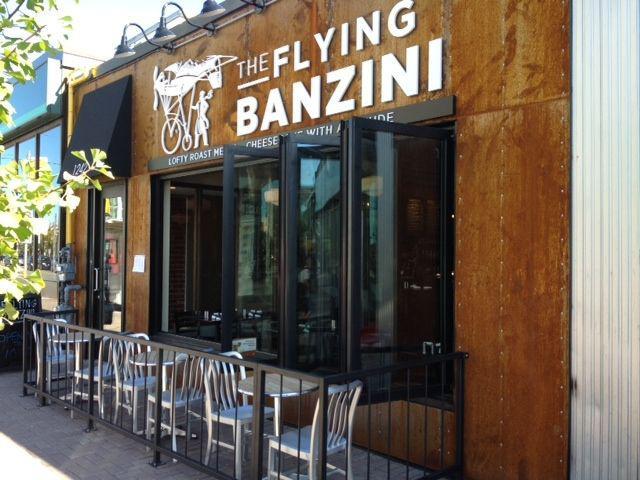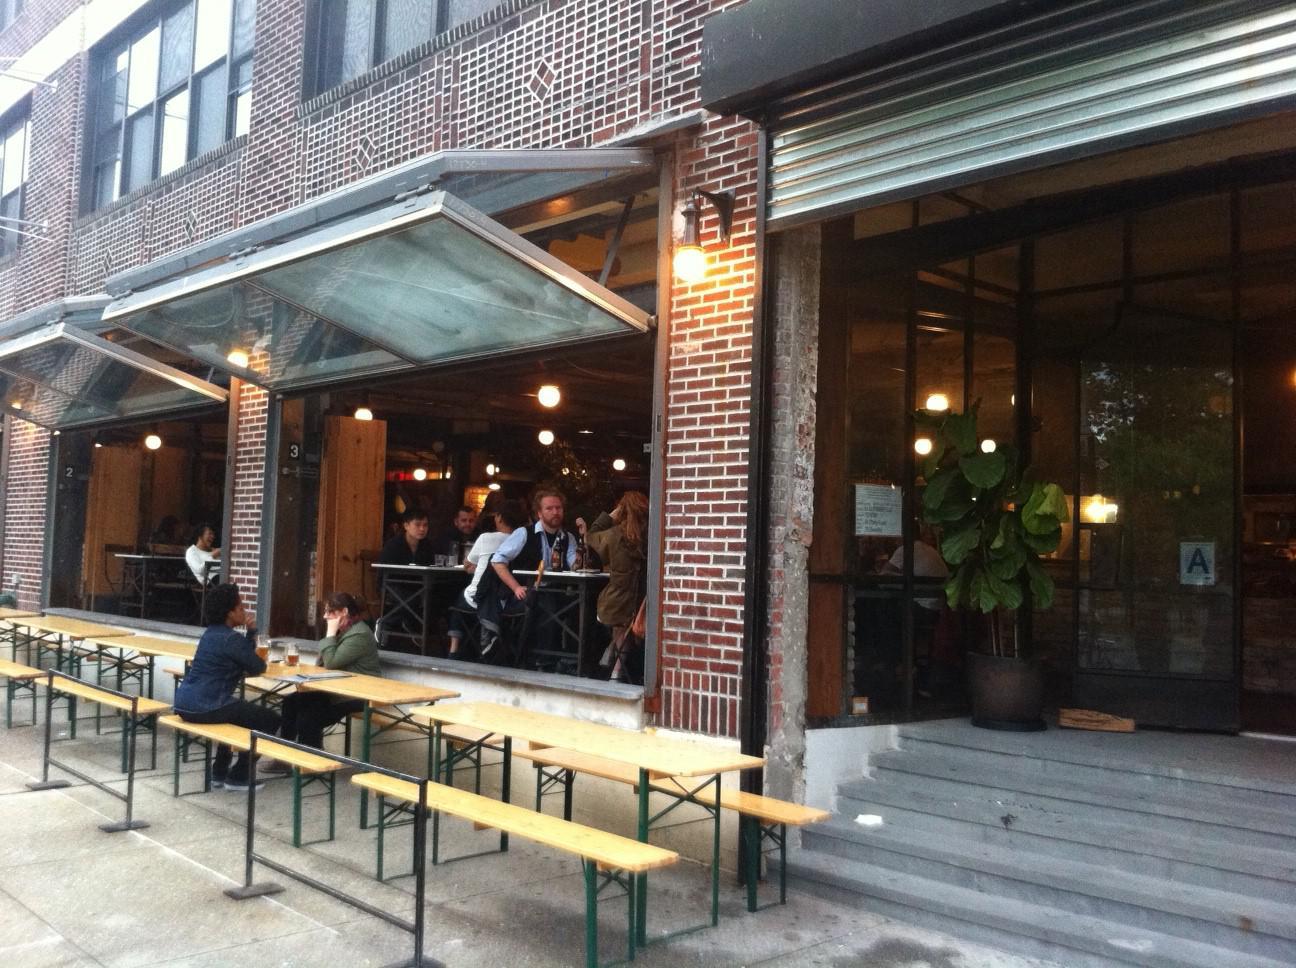The first image is the image on the left, the second image is the image on the right. Analyze the images presented: Is the assertion "One image is inside and one is outside." valid? Answer yes or no. No. The first image is the image on the left, the second image is the image on the right. Examine the images to the left and right. Is the description "There is a five glass panel and black trim set of doors acorning." accurate? Answer yes or no. No. 